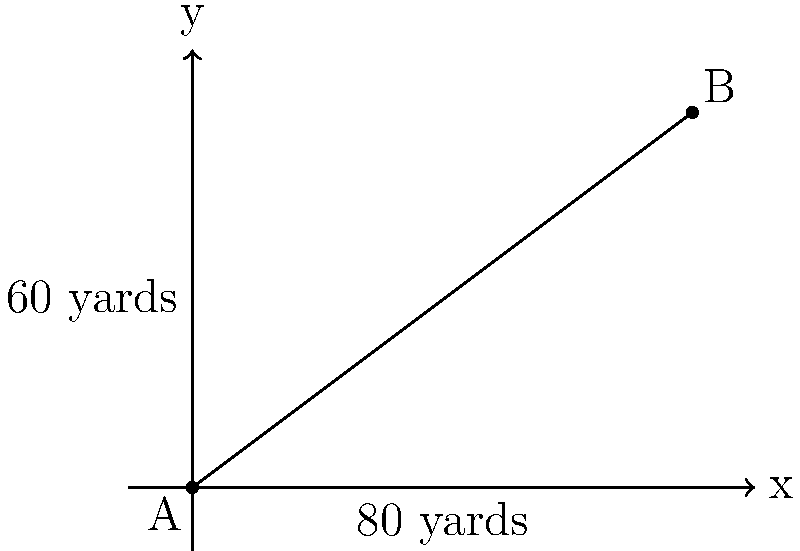In an American football stadium, two goal posts are positioned at points A(0,0) and B(80,60) on a coordinate plane, where each unit represents 1 yard. Using the distance formula, calculate the straight-line distance between these two goal posts. Round your answer to the nearest yard. To solve this problem, we'll use the distance formula:

$$d = \sqrt{(x_2 - x_1)^2 + (y_2 - y_1)^2}$$

Where $(x_1, y_1)$ are the coordinates of point A and $(x_2, y_2)$ are the coordinates of point B.

Step 1: Identify the coordinates
A(0,0) and B(80,60)

Step 2: Plug the values into the distance formula
$$d = \sqrt{(80 - 0)^2 + (60 - 0)^2}$$

Step 3: Simplify
$$d = \sqrt{80^2 + 60^2}$$
$$d = \sqrt{6400 + 3600}$$

Step 4: Calculate
$$d = \sqrt{10000}$$
$$d = 100$$

Step 5: Round to the nearest yard
The distance is already a whole number, so no rounding is necessary.

Therefore, the straight-line distance between the two goal posts is 100 yards.
Answer: 100 yards 